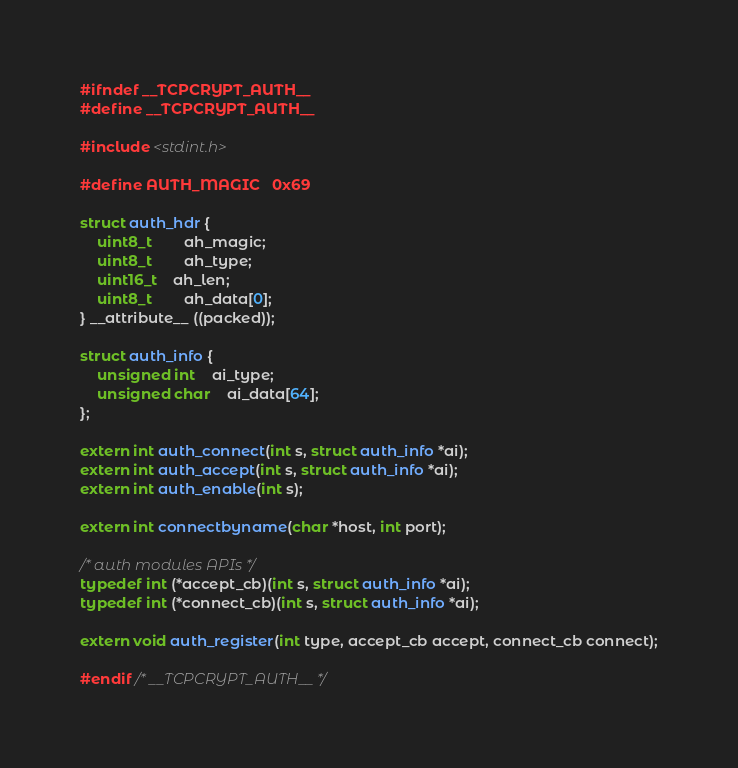<code> <loc_0><loc_0><loc_500><loc_500><_C_>#ifndef __TCPCRYPT_AUTH__
#define __TCPCRYPT_AUTH__

#include <stdint.h>

#define AUTH_MAGIC	0x69

struct auth_hdr {
	uint8_t		ah_magic;
	uint8_t		ah_type;
	uint16_t	ah_len;
	uint8_t		ah_data[0];
} __attribute__ ((packed));

struct auth_info {
	unsigned int	ai_type;
	unsigned char	ai_data[64];
};

extern int auth_connect(int s, struct auth_info *ai);
extern int auth_accept(int s, struct auth_info *ai);
extern int auth_enable(int s);

extern int connectbyname(char *host, int port);

/* auth modules APIs */
typedef int (*accept_cb)(int s, struct auth_info *ai);
typedef int (*connect_cb)(int s, struct auth_info *ai);

extern void auth_register(int type, accept_cb accept, connect_cb connect);

#endif /* __TCPCRYPT_AUTH__ */
</code> 